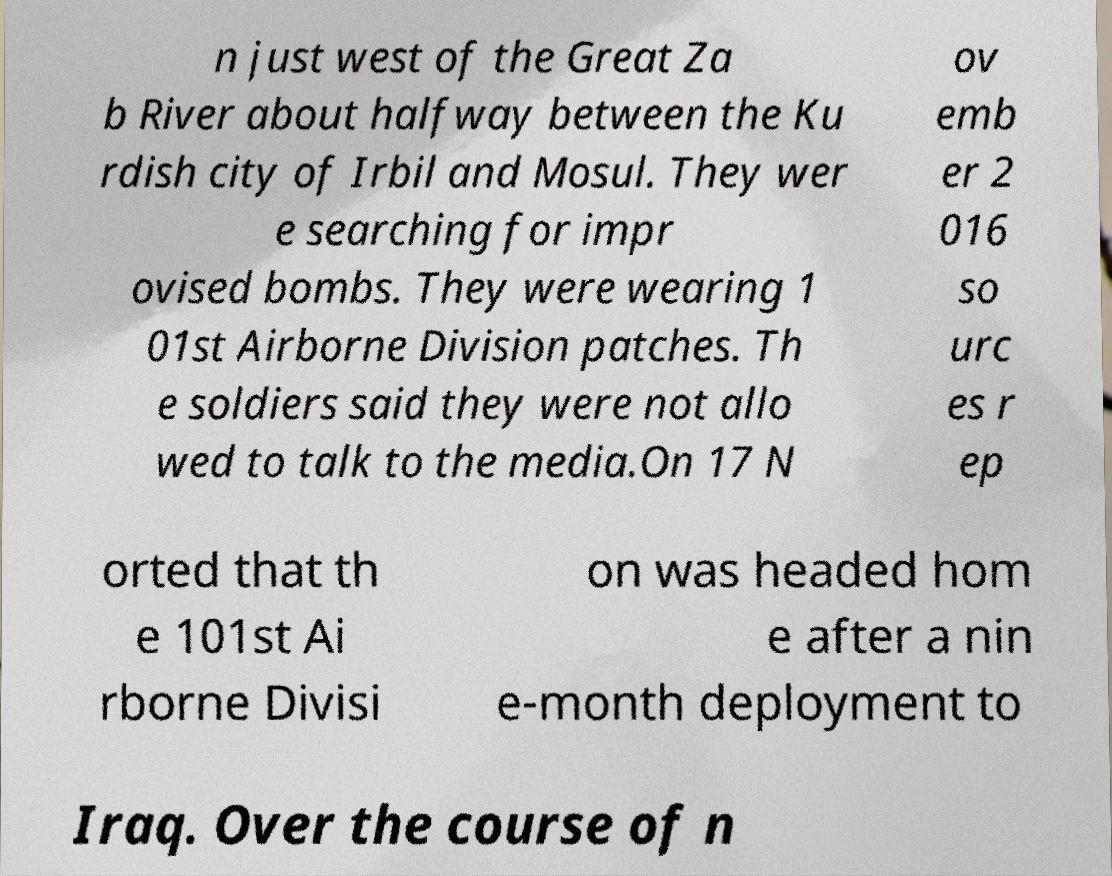I need the written content from this picture converted into text. Can you do that? n just west of the Great Za b River about halfway between the Ku rdish city of Irbil and Mosul. They wer e searching for impr ovised bombs. They were wearing 1 01st Airborne Division patches. Th e soldiers said they were not allo wed to talk to the media.On 17 N ov emb er 2 016 so urc es r ep orted that th e 101st Ai rborne Divisi on was headed hom e after a nin e-month deployment to Iraq. Over the course of n 